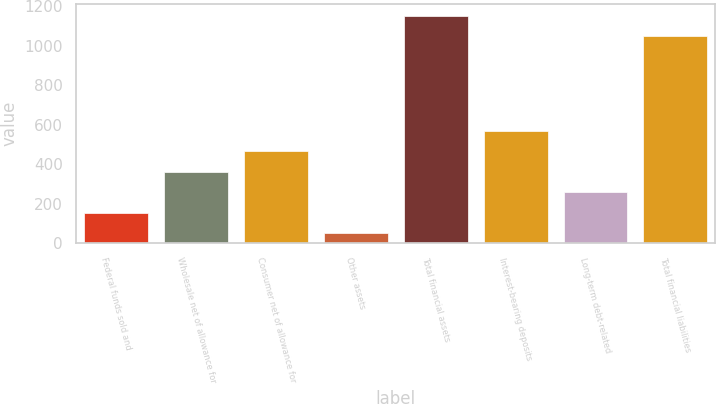Convert chart. <chart><loc_0><loc_0><loc_500><loc_500><bar_chart><fcel>Federal funds sold and<fcel>Wholesale net of allowance for<fcel>Consumer net of allowance for<fcel>Other assets<fcel>Total financial assets<fcel>Interest-bearing deposits<fcel>Long-term debt-related<fcel>Total financial liabilities<nl><fcel>155.02<fcel>362.86<fcel>466.78<fcel>51.1<fcel>1152.92<fcel>570.7<fcel>258.94<fcel>1049<nl></chart> 